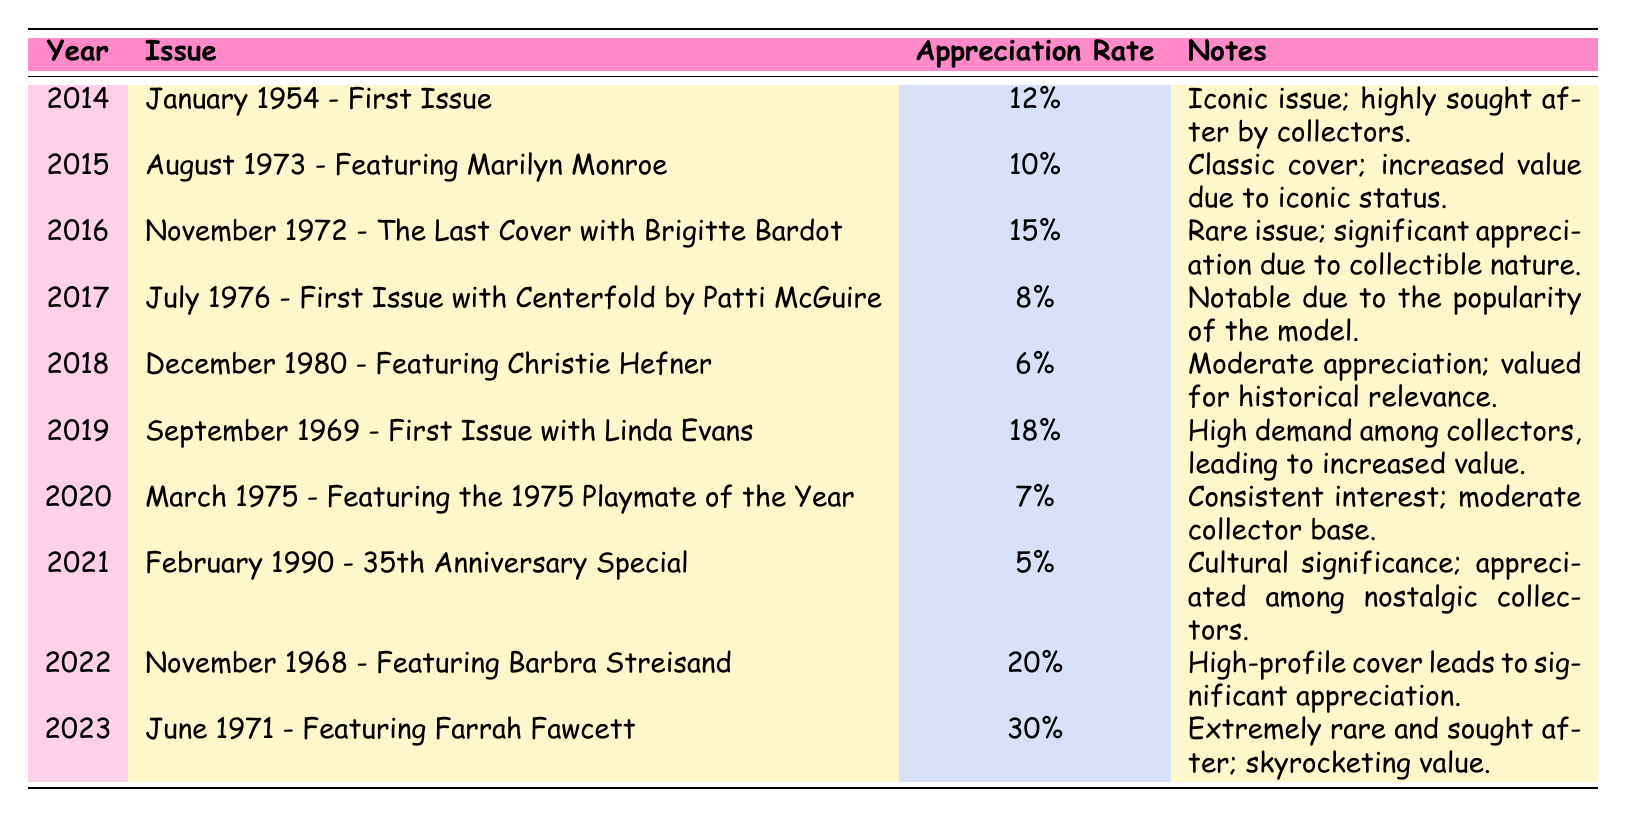What was the appreciation rate of the January 1954 issue? The table shows that the appreciation rate for the January 1954 issue is listed under the 2014 row, which states it is 12%.
Answer: 12% Which Playboy issue had the highest appreciation rate? By scanning the appreciation rates in the table, the highest value is 30% for the June 1971 issue.
Answer: June 1971 - Featuring Farrah Fawcett How many issues had an appreciation rate higher than 10%? The issues with appreciation rates higher than 10% are: January 1954 (12%), November 1972 (15%), September 1969 (18%), November 1968 (20%), and June 1971 (30%). This totals to five issues.
Answer: 5 What is the average appreciation rate of the selected issues from 2014 to 2023? First, we sum the appreciation rates: 12 + 10 + 15 + 8 + 6 + 18 + 7 + 5 + 20 + 30 = 131. Then we divide by the total number of issues (10): 131 / 10 = 13.1%.
Answer: 13.1% Is the appreciation rate of the August 1973 issue greater than the appreciation rate of the July 1976 issue? The appreciation rate for the August 1973 issue is 10%, while for the July 1976 issue it is 8%. Since 10% is greater than 8%, the statement is true.
Answer: Yes Did any issue released in 2021 have an appreciation rate of more than 10%? The only issue listed for 2021 is the February 1990 special with an appreciation rate of 5%. Since this rate is not greater than 10%, the statement is false.
Answer: No Which issue saw a decline in appreciation rate from the previous year? The appreciation rate of 2017 (8%) is lower than that of 2016 (15%). Therefore, the July 1976 issue saw a decline from the November 1972 issue.
Answer: July 1976 - First Issue with Centerfold by Patti McGuire What was the appreciation rate change from 2022 to 2023? In 2022, the appreciation rate was 20%, and in 2023 it rose to 30%. The change is 30% - 20% = 10%.
Answer: 10% 